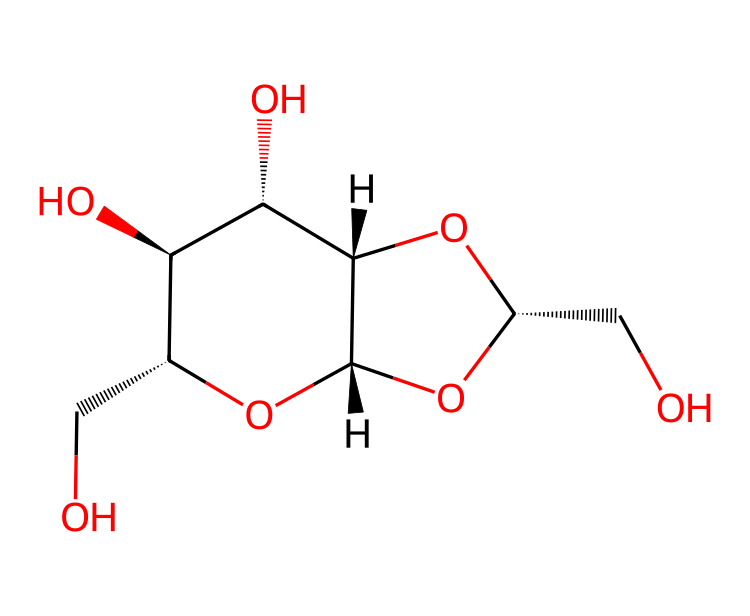how many carbon atoms are present in the structure? By analyzing the SMILES representation, we can identify that the chemical has several carbon atoms represented by "C". Counting each "C" in the structure yields a total of 6 carbon atoms.
Answer: 6 how many hydroxyl (−OH) groups are present? The presence of hydroxyl groups can be identified from the "O" atoms connected to carbon atoms in the structure. Each "O" connected to a "C" with a hydrogen represents a hydroxyl group. There are 5 such connections in the SMILES structure.
Answer: 5 what type of polymer is this chemical? The structure indicates that this chemical is a polysaccharide due to the presence of multiple monosaccharide units linked together. The repeating units of sugars confirm that it is nanocellulose.
Answer: polysaccharide what is the primary application of this chemical in packaging? The nanocellulose derived from this structure is primarily used in eco-friendly packaging due to its biodegradable properties and strength as a substitute for plastics. This makes it appealing for sustainable packaging solutions.
Answer: biodegradable packaging explain how nanocellulose can contribute to sustainability in international trade. Nanocellulose, as displayed in this chemical structure, is renewable and biodegradable, making it a sustainable alternative to traditional packaging materials. It can reduce plastic waste in international trade while providing a sturdy and lightweight option for shipping goods, aligning with eco-friendly practices.
Answer: renewable and biodegradable 